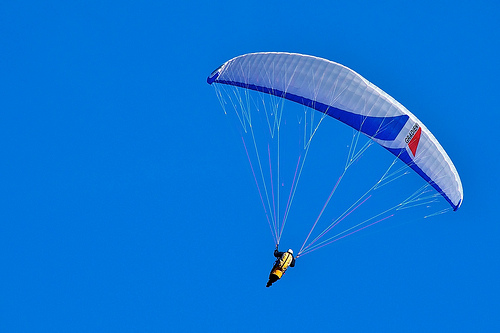What safety measures can you identify in this image? In the image, the person is wearing a helmet, which is a crucial safety measure to protect their head. The yellow vest could also have reflective properties, and the cords they are holding onto are vital for controlling their descent. Additionally, the parachute looks sturdy and properly attached, which is essential for a safe flight. Imagine a scenario where the person encounters sudden turbulence. What actions might they take? In the event of sudden turbulence, the person would need to remain calm and focused. They would likely adjust the tension on the cords to stabilize the parachute and regain control. If the turbulence is severe, they might also look for a safe area to descend and prepare for an emergency landing. Overall, maintaining a steady grip and keeping their movements controlled and deliberate would be crucial. 